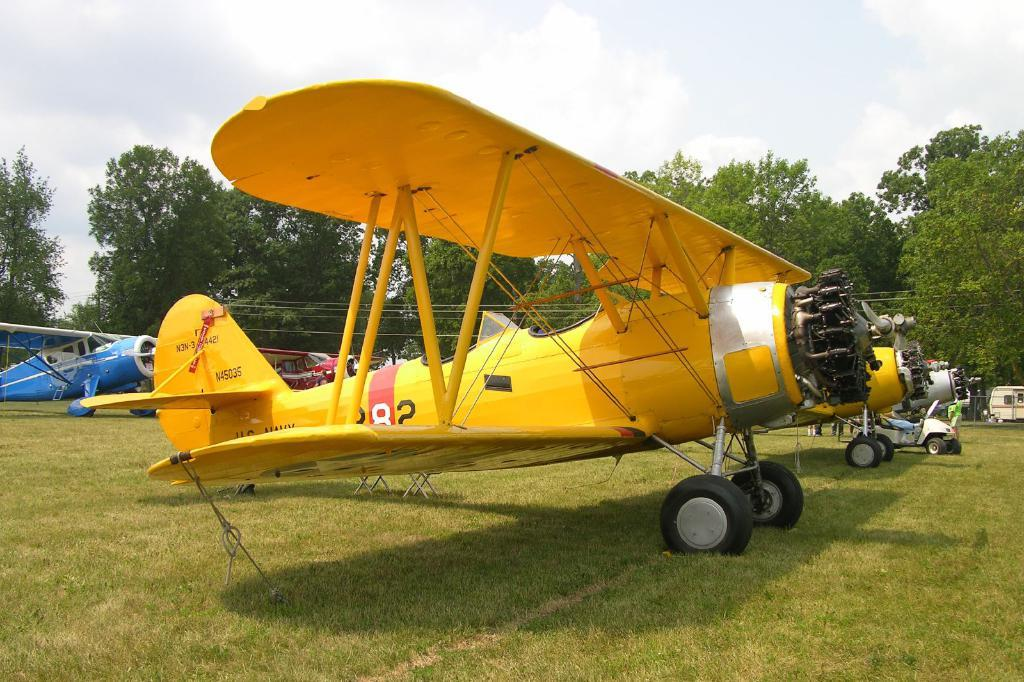Provide a one-sentence caption for the provided image. a yellow plane with N45035 written on the tail. 